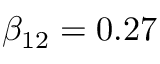<formula> <loc_0><loc_0><loc_500><loc_500>\beta _ { 1 2 } = 0 . 2 7</formula> 